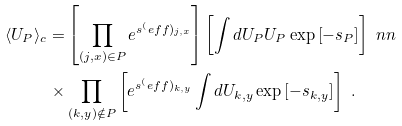<formula> <loc_0><loc_0><loc_500><loc_500>\langle U _ { P } \rangle _ { c } = & \left [ \prod _ { ( j , x ) \in P } e ^ { s ^ { ( } e f f ) _ { j , x } } \right ] \left [ \int d U _ { P } U _ { P } \exp \left [ - s _ { P } \right ] \right ] \ n n \\ \times & \prod _ { ( k , y ) \notin P } \left [ e ^ { s ^ { ( } e f f ) _ { k , y } } \int d U _ { k , y } \exp \left [ - s _ { k , y } \right ] \right ] \ .</formula> 